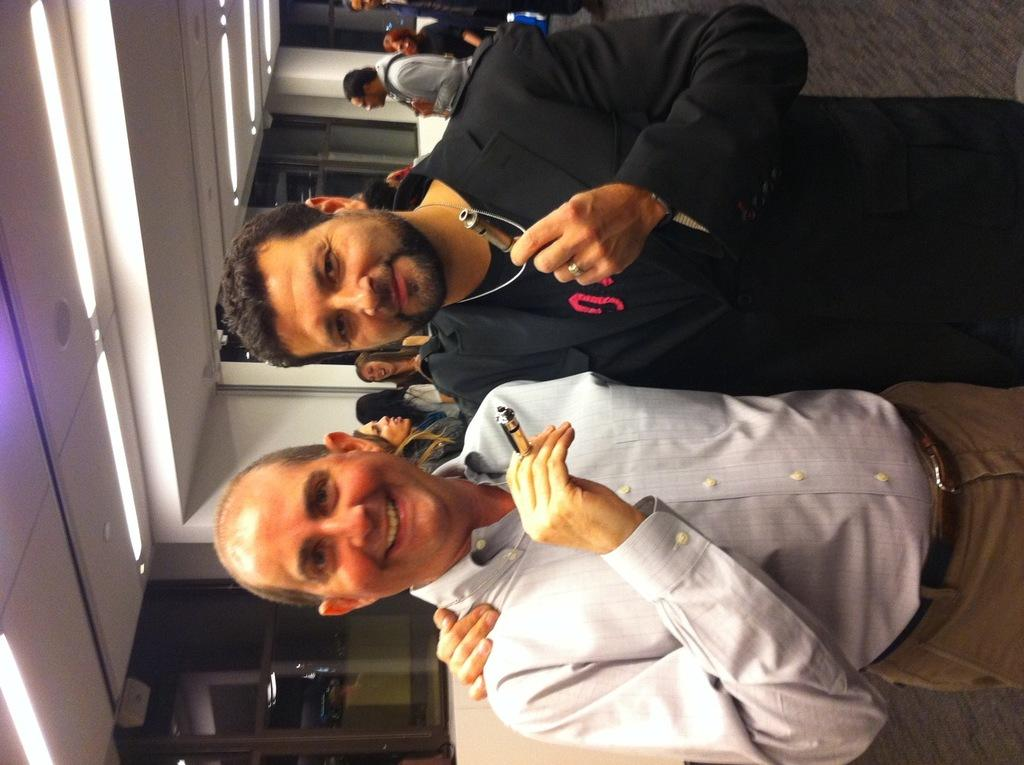Who or what can be seen in the image? There are people in the image. What else is visible in the image besides the people? There are lights visible in the image. How much honey is being consumed by the people in the image? There is no honey present in the image, so it cannot be determined how much honey is being consumed. 